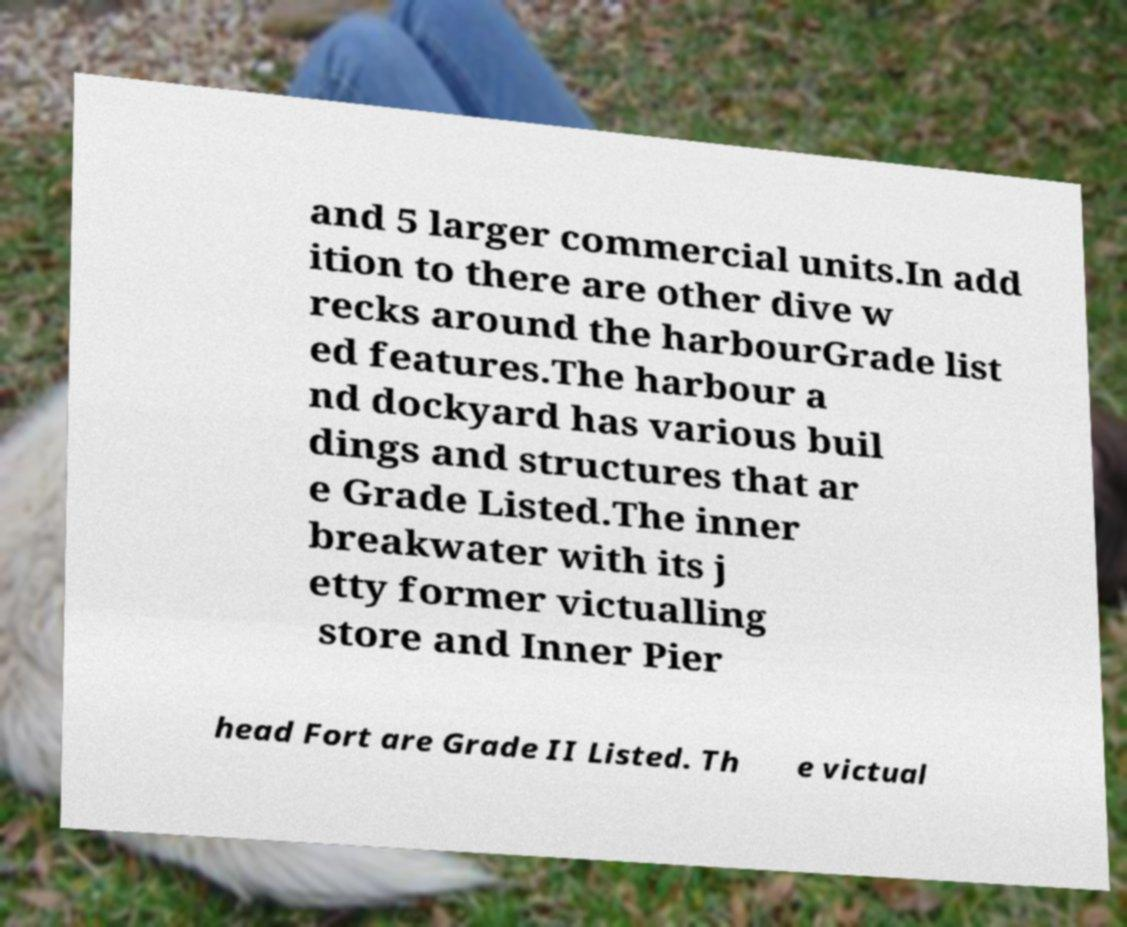What messages or text are displayed in this image? I need them in a readable, typed format. and 5 larger commercial units.In add ition to there are other dive w recks around the harbourGrade list ed features.The harbour a nd dockyard has various buil dings and structures that ar e Grade Listed.The inner breakwater with its j etty former victualling store and Inner Pier head Fort are Grade II Listed. Th e victual 